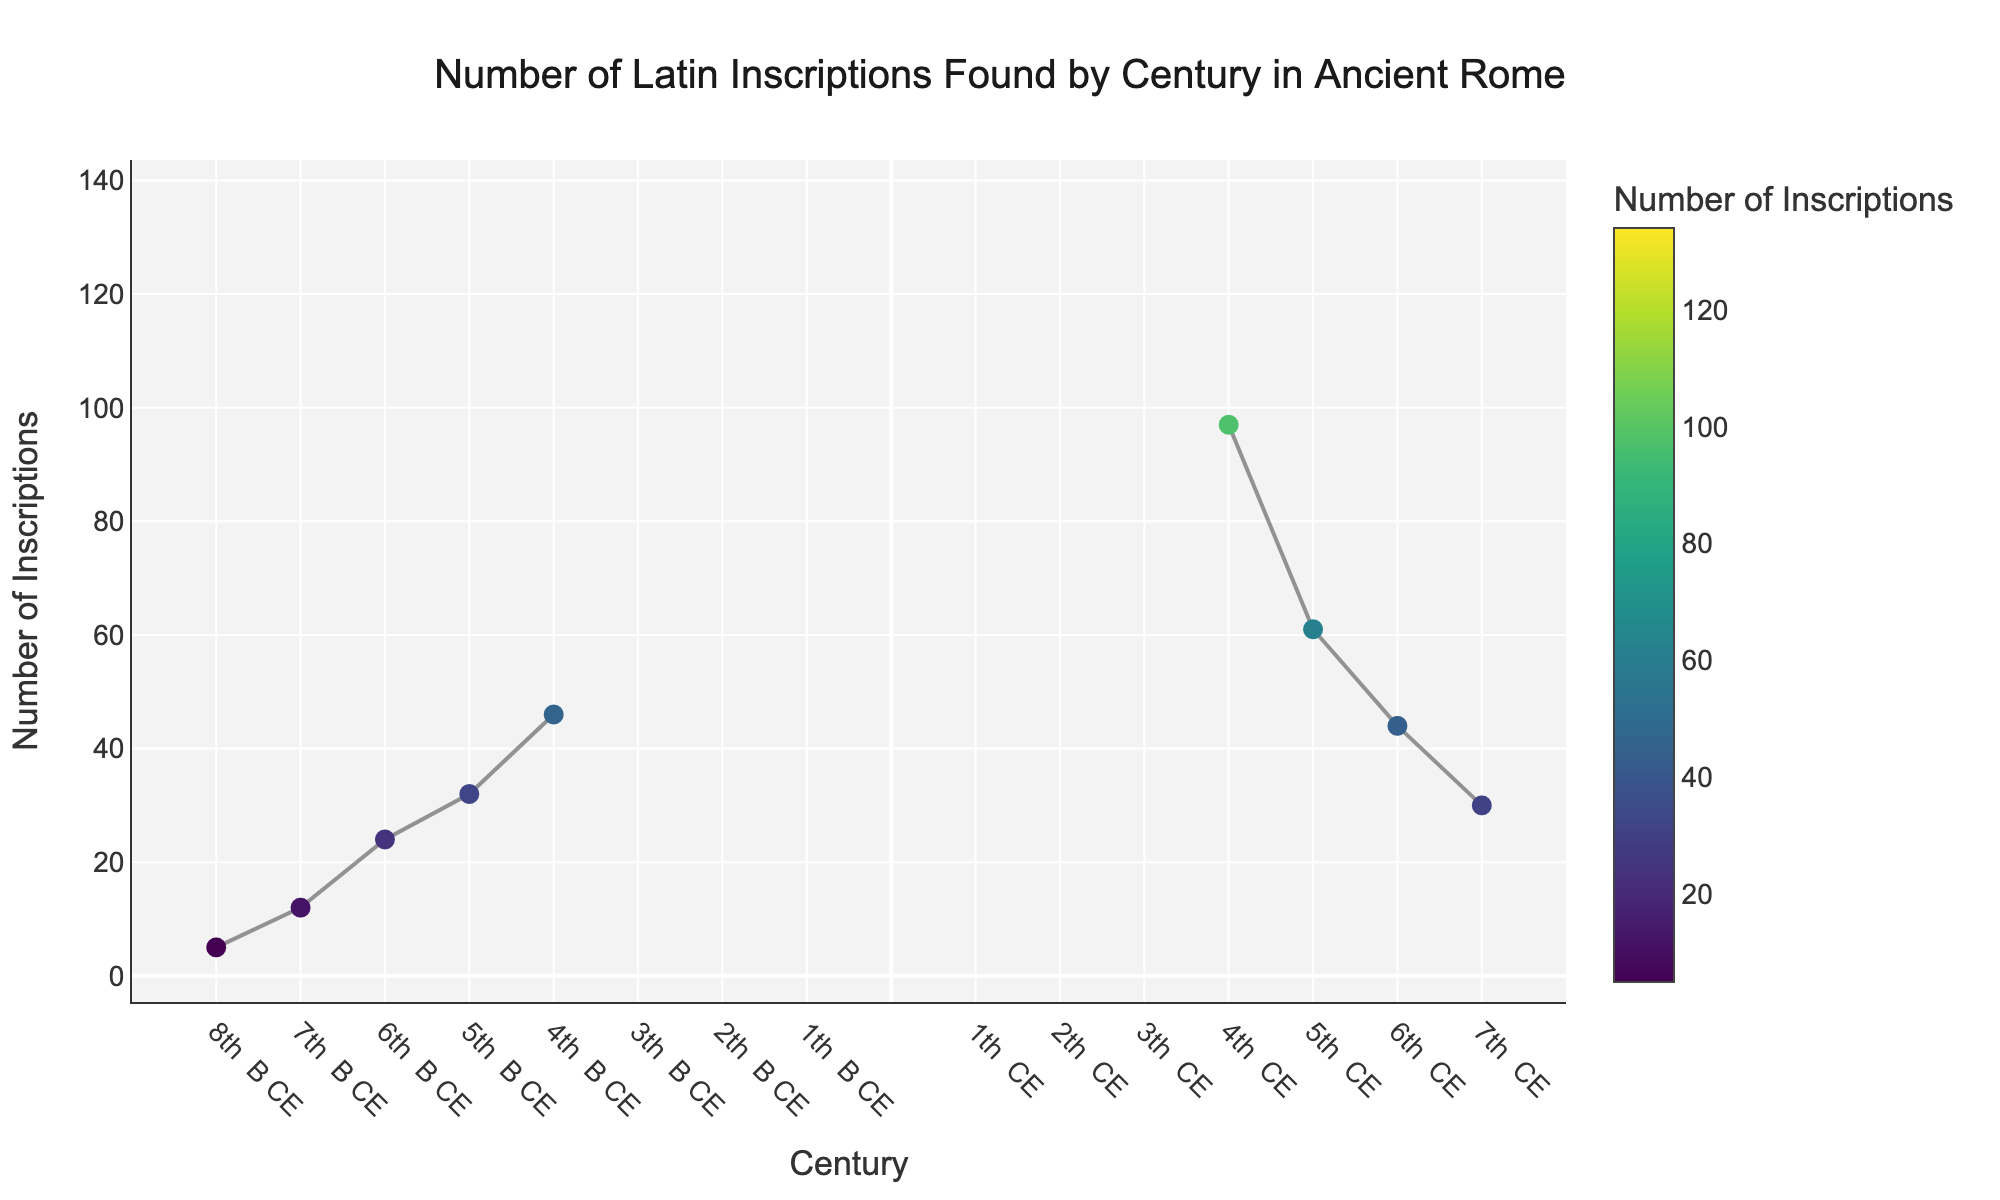What's the title of the figure? The title of the figure is displayed at the top of the plot and helps to understand the context and focus of the data being visualized.
Answer: Number of Latin Inscriptions Found by Century in Ancient Rome What is the highest number of Latin inscriptions found in a single century? To find this, look for the peak value on the y-axis and identify the corresponding number.
Answer: 134 In which century was the highest number of Latin inscriptions found? First, identify the highest number of inscriptions (134), then look at the corresponding century on the x-axis.
Answer: 2nd CE Compare the number of inscriptions found in the 4th BCE and the 4th CE. Which century had more? Identify the inscriptions for both centuries from the y-values: 46 (4th BCE) and 97 (4th CE), and compare them.
Answer: 4th CE had more How many centuries have more than 100 Latin inscriptions found? Count the number of data points where the y-value exceeds 100.
Answer: 3 What is the average number of inscriptions found in the **1st BCE**, **1st CE**, and **2nd CE**? Sum the values for these three centuries (89, 120, 134) and divide by 3 to get the average: (89 + 120 + 134) / 3 = 343 / 3 = ~114.33
Answer: ~114 By how many did the number of inscriptions increase from the 8th BCE to the 1st BCE? Subtract the number of inscriptions in 8th BCE from 1st BCE: 89 - 5 = 84.
Answer: 84 Which century experienced the most significant decrease in the number of inscriptions compared to the preceding century? Subtract the inscriptions of each century from the preceding one and find the greatest decrease: The 3rd CE to the 4th CE is the highest, with 134 - 118 = 16.
Answer: 3rd CE to 4th CE What century marks a clear decline in the number of inscriptions found after peaking? Identify the peak (134 in the 2nd CE) and observe the subsequent data points to see when the decline starts: 3rd CE shows a decline.
Answer: 3rd CE How many centuries are represented in the plot? Count the number of data points or x-ticks corresponding to each century.
Answer: 15 